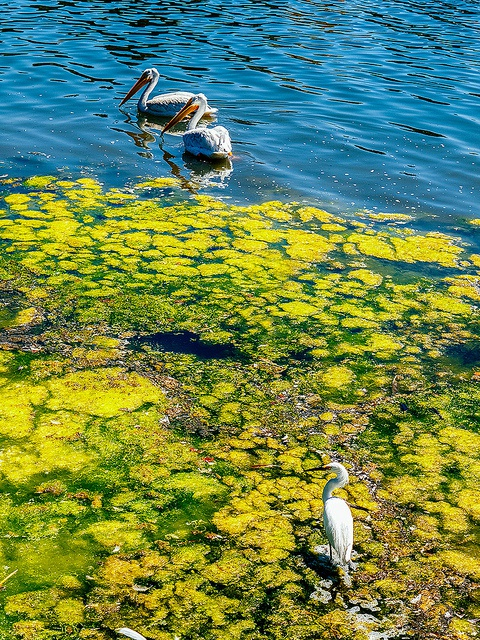Describe the objects in this image and their specific colors. I can see bird in teal, white, and darkgray tones, bird in teal, black, lightgray, navy, and blue tones, and bird in teal, white, navy, darkgray, and black tones in this image. 